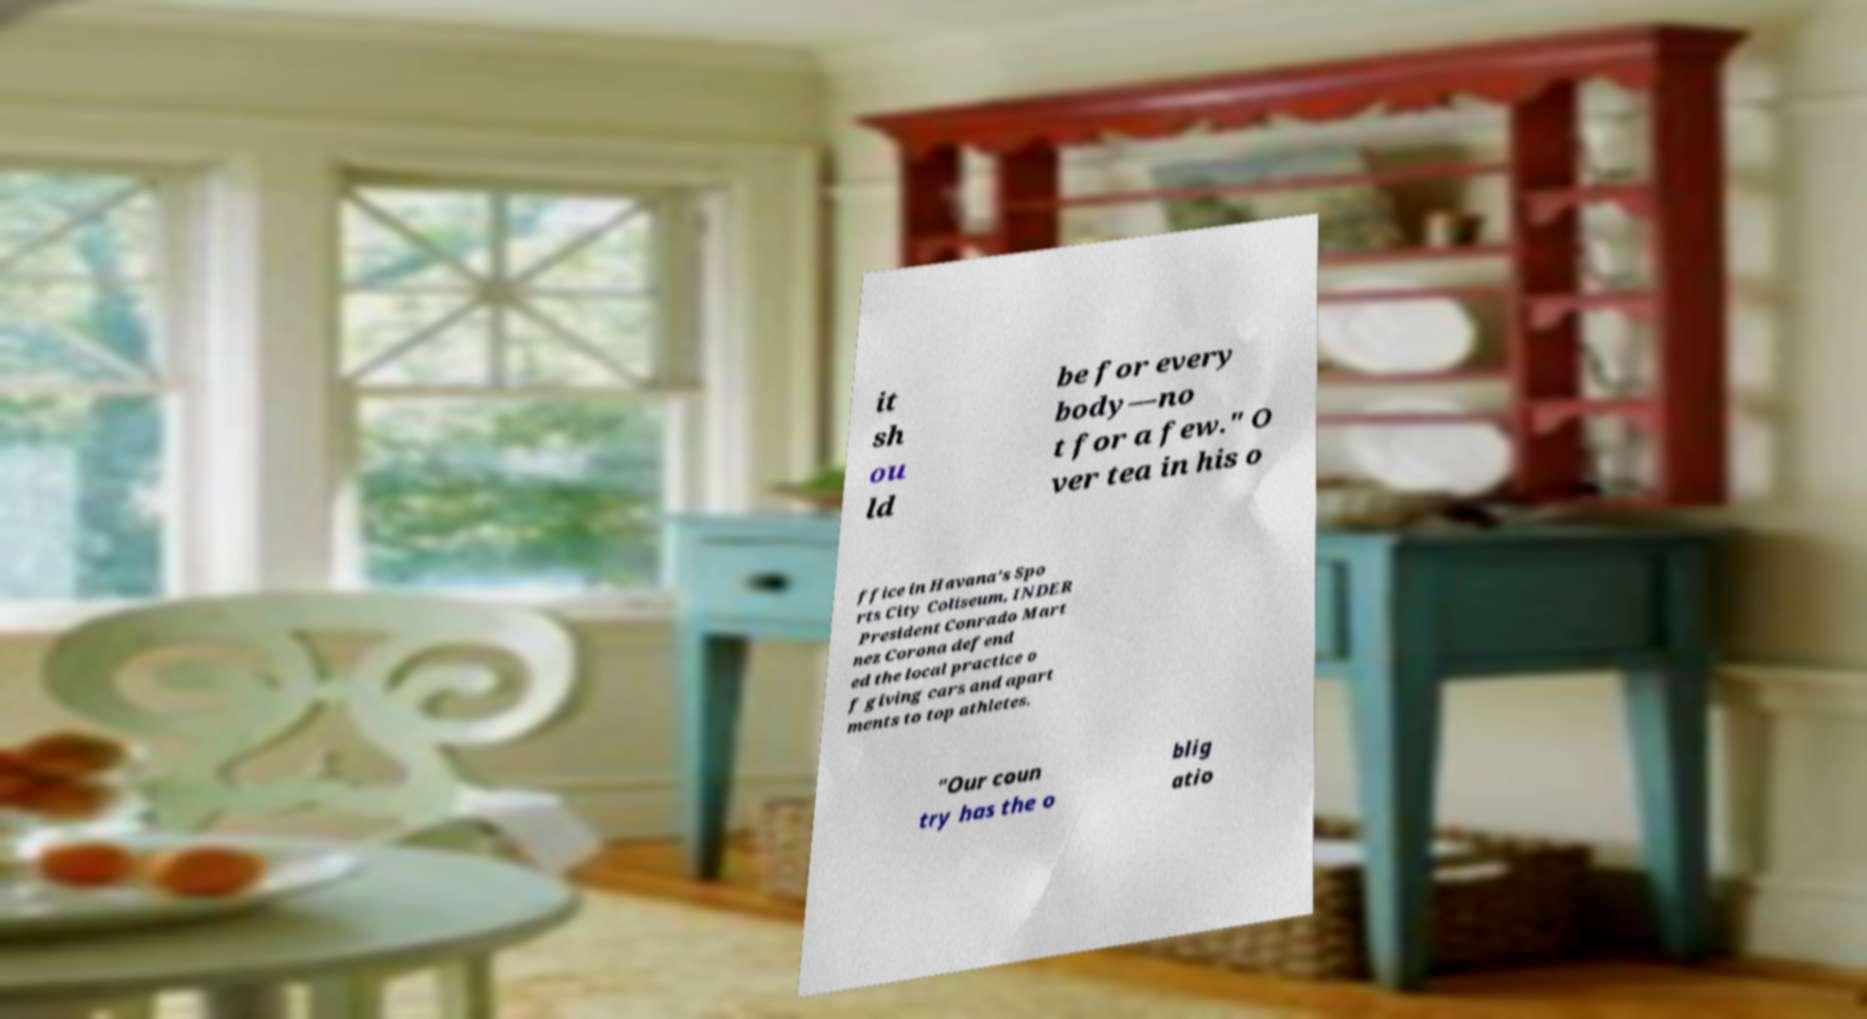For documentation purposes, I need the text within this image transcribed. Could you provide that? it sh ou ld be for every body—no t for a few." O ver tea in his o ffice in Havana's Spo rts City Coliseum, INDER President Conrado Mart nez Corona defend ed the local practice o f giving cars and apart ments to top athletes. "Our coun try has the o blig atio 